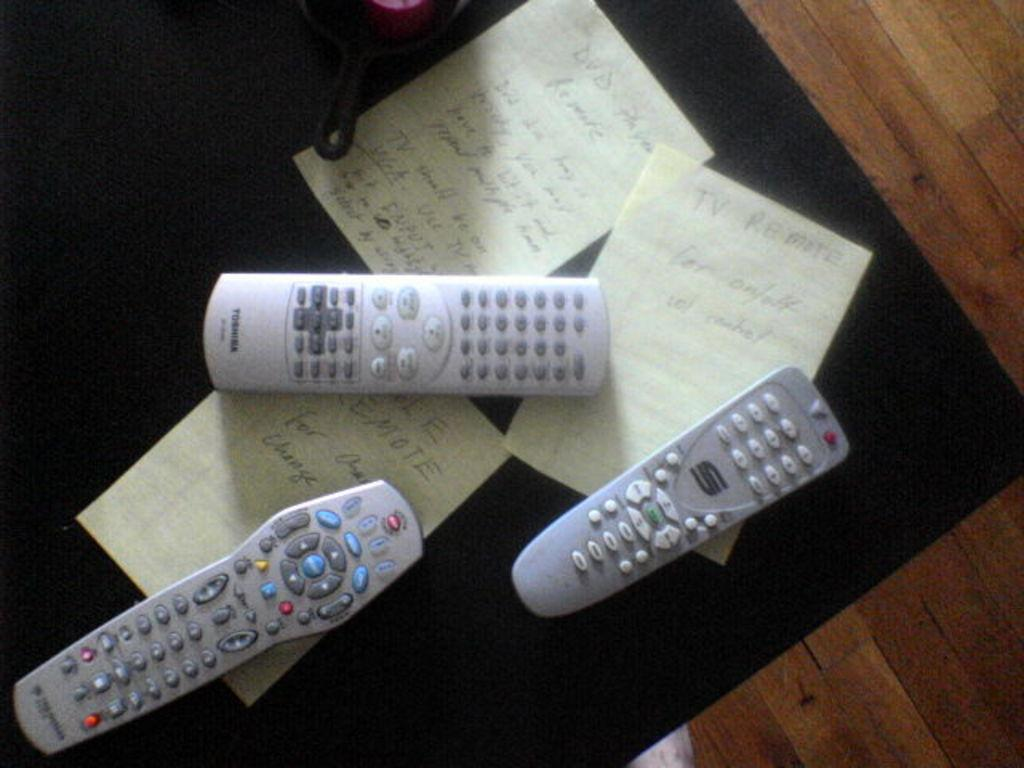<image>
Present a compact description of the photo's key features. Three sheets of paper on a black table are held down remotes including on made by Toshiba. 